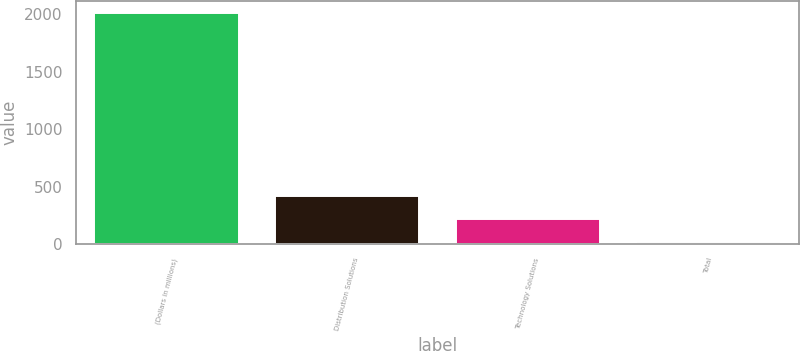<chart> <loc_0><loc_0><loc_500><loc_500><bar_chart><fcel>(Dollars in millions)<fcel>Distribution Solutions<fcel>Technology Solutions<fcel>Total<nl><fcel>2011<fcel>415<fcel>215.5<fcel>16<nl></chart> 